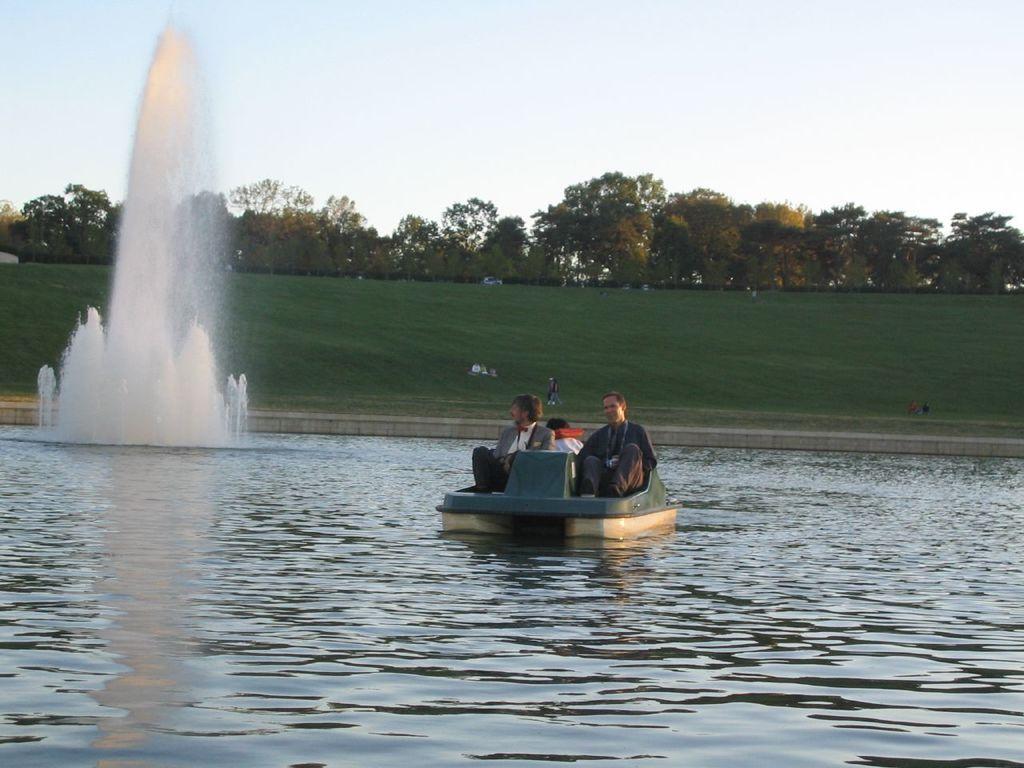Can you describe this image briefly? This picture is taken from outside of the city. In this image, in the middle, we can see a boat, in the boat, we can see two men are sitting. On the left side, we can see a fountain. In the background, we can see some trees and plants, vehicles. At the top, we can see a sky, at the bottom, we can see a grass and water in a lake. 